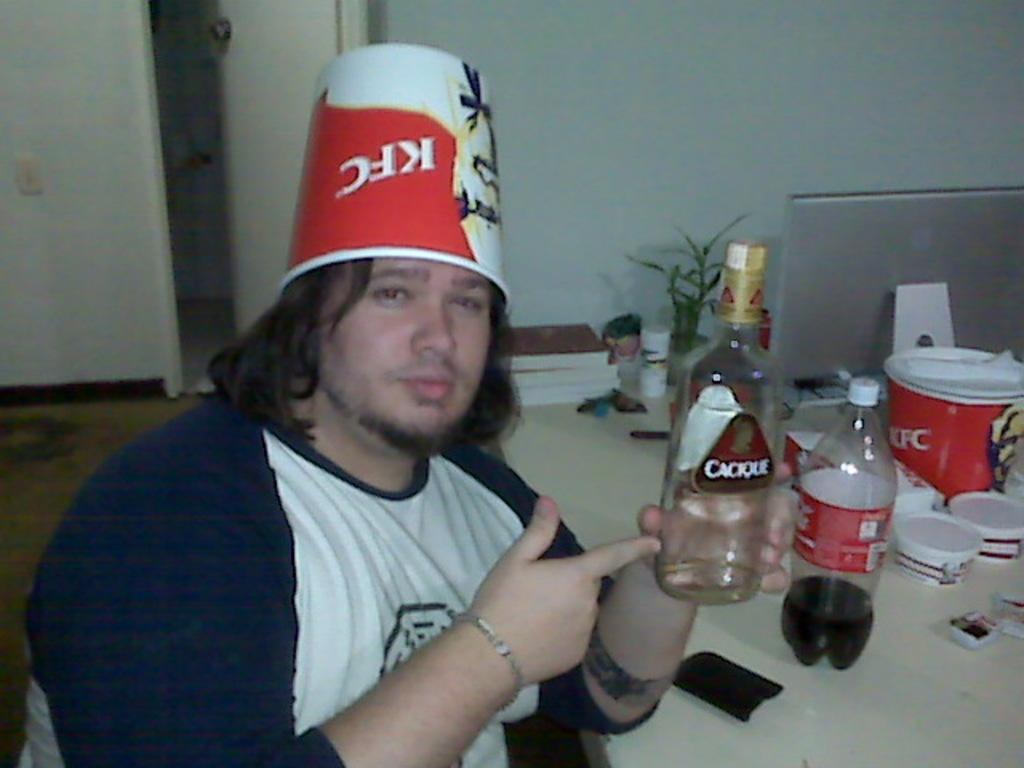Please provide a concise description of this image. In this image I see a man who is holding a bottle and there is a box on his head. I see a table in front of him on which there is another bottle, few cups, two boxes, books and a plant. In the background I see the wall, a laptop and the door. 